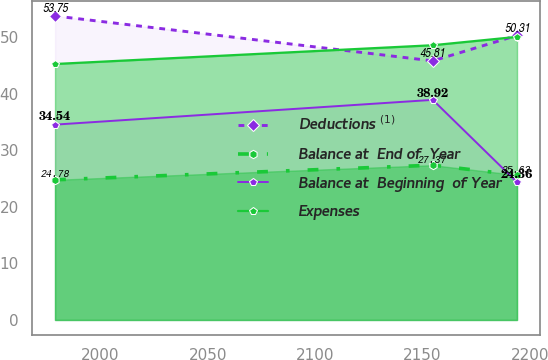Convert chart to OTSL. <chart><loc_0><loc_0><loc_500><loc_500><line_chart><ecel><fcel>Deductions $^{(1)}$<fcel>Balance at  End of  Year<fcel>Balance at  Beginning  of Year<fcel>Expenses<nl><fcel>1978.84<fcel>53.75<fcel>24.78<fcel>34.54<fcel>45.26<nl><fcel>2154.8<fcel>45.81<fcel>27.37<fcel>38.92<fcel>48.58<nl><fcel>2194.03<fcel>50.31<fcel>25.63<fcel>24.36<fcel>50.06<nl></chart> 